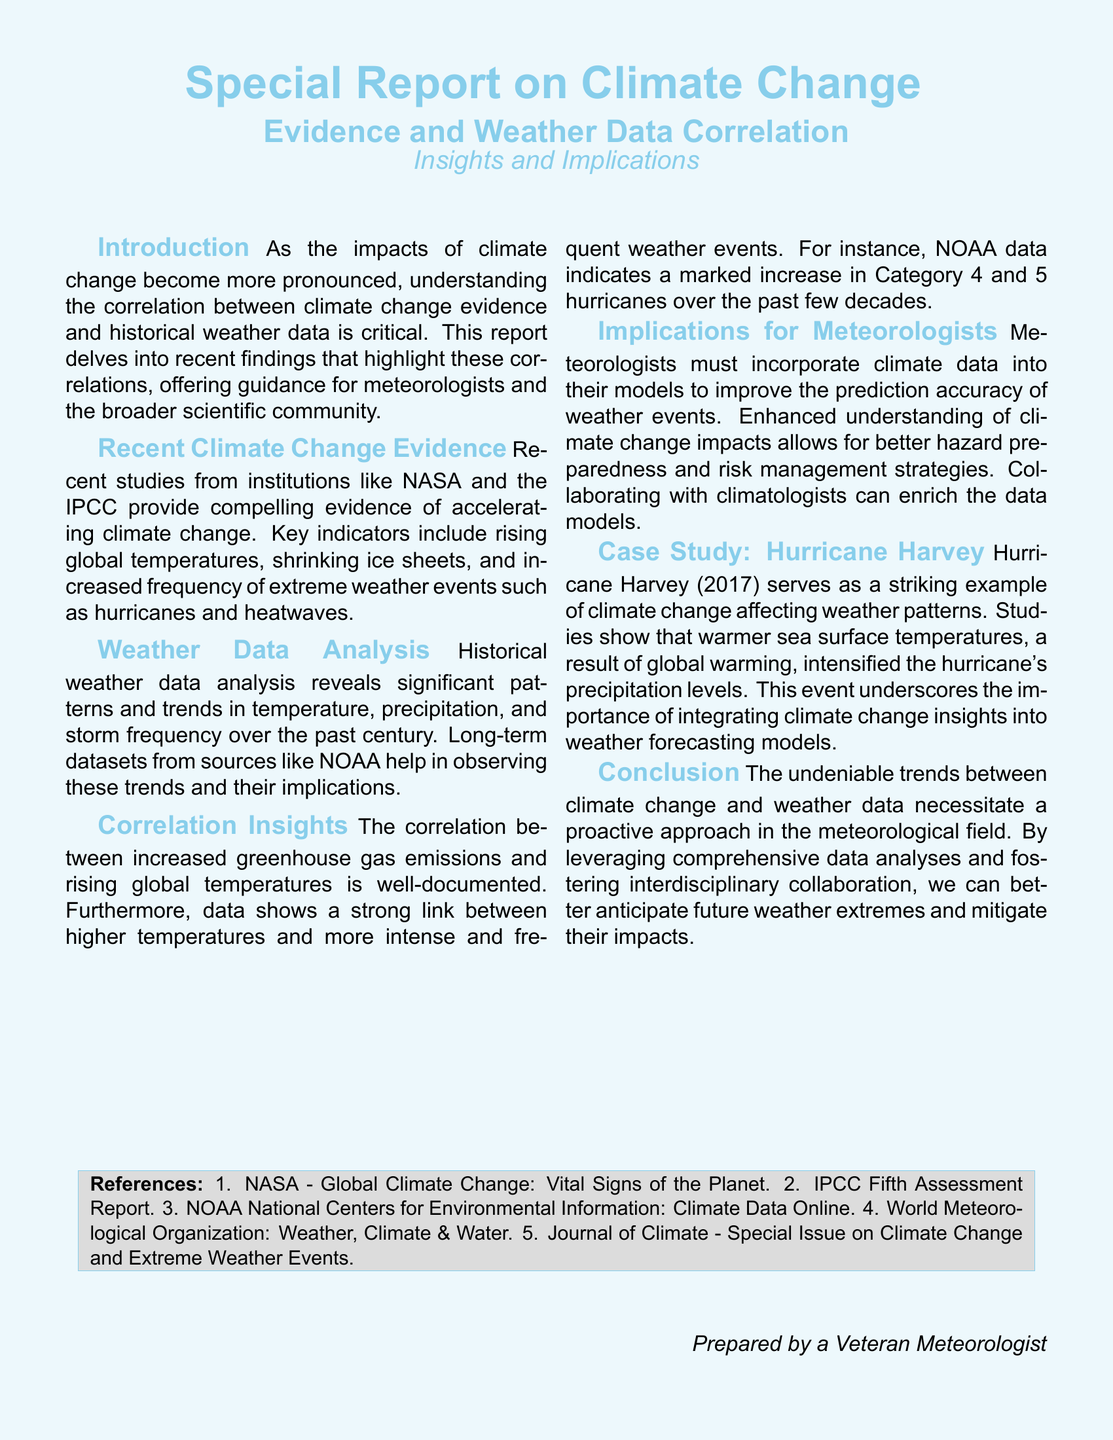What is the main focus of the report? The report focuses on the correlation between climate change evidence and historical weather data.
Answer: Correlation between climate change evidence and historical weather data What year did Hurricane Harvey occur? The document mentions Hurricane Harvey occurred in the year 2017.
Answer: 2017 What institution is mentioned alongside NASA for climate change studies? The document refers to the IPCC as an institution providing data on climate change.
Answer: IPCC What type of weather event has increased in frequency according to NOAA data? The document indicates that there is a marked increase in Category 4 and 5 hurricanes.
Answer: Category 4 and 5 hurricanes What are meteorologists encouraged to do with climate data? Meteorologists are encouraged to incorporate climate data into their models for better accuracy.
Answer: Incorporate climate data into their models What significant trend is mentioned in the document regarding sea surface temperatures? The document highlights that warmer sea surface temperatures intensified Hurricane Harvey's precipitation levels.
Answer: Warmer sea surface temperatures What color is used for the background of the document? The document uses a light sky blue color for the background.
Answer: Light sky blue What does the report suggest for future weather extremes? The report suggests leveraging comprehensive data analyses and fostering interdisciplinary collaboration.
Answer: Leverage comprehensive data analyses and foster interdisciplinary collaboration 